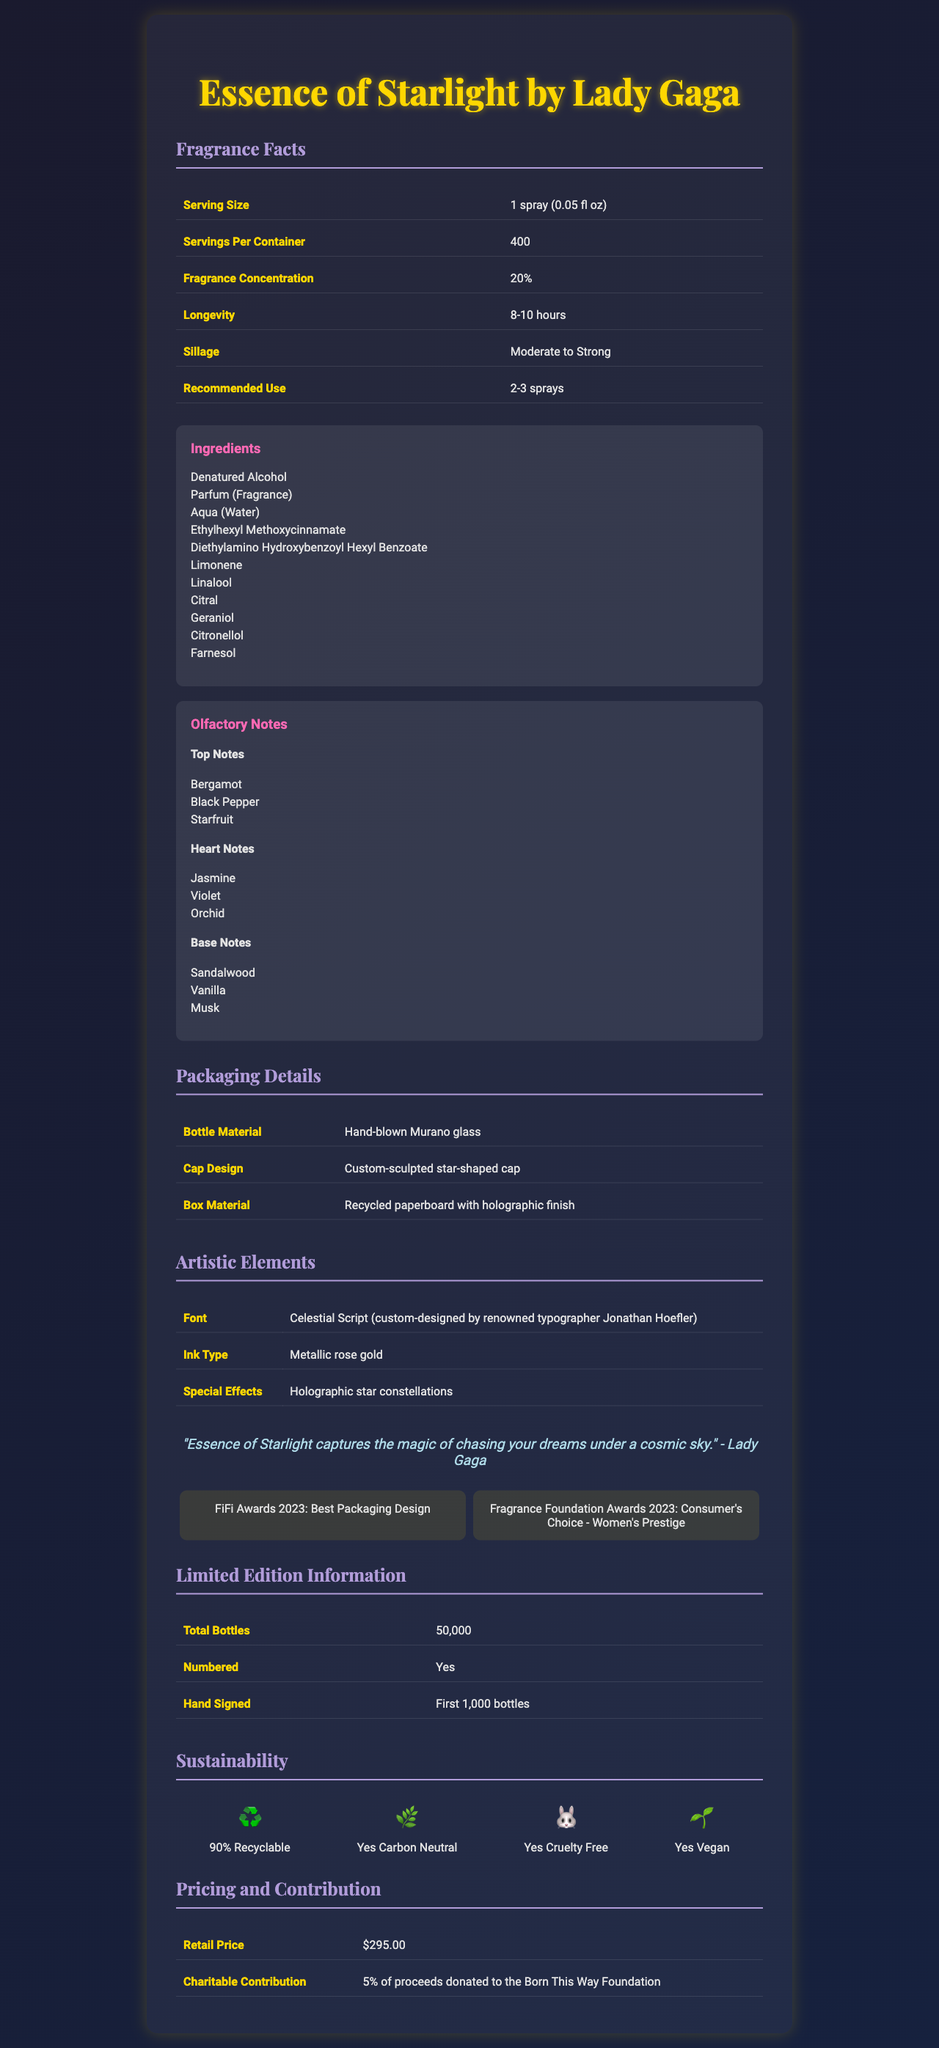what is the product name? The product name is listed at the top of the document and prominently titled "Essence of Starlight by Lady Gaga".
Answer: Essence of Starlight by Lady Gaga what is the fragrance concentration percentage? The fragrance concentration of the perfume is given in the Fragrance Facts table as 20%.
Answer: 20% what are the top notes of the perfume? The top notes are listed under the olfactory notes section of the document.
Answer: Bergamot, Black Pepper, Starfruit what material is the bottle made of? The bottle material is listed under the Packaging Details section.
Answer: Hand-blown Murano glass who custom-designed the font used in this document? The font, named Celestial Script, is custom-designed by renowned typographer Jonathan Hoefler and is detailed under Artistic Elements.
Answer: Jonathan Hoefler what is the retail price of the perfume? The retail price is mentioned in the Pricing and Contribution section as $295.00.
Answer: $295.00 how long does the fragrance last? (Longevity) The longevity of the fragrance is stated in the Fragrance Facts table as 8-10 hours.
Answer: 8-10 hours what special effects are incorporated in the packaging design? A. Metallic shimmer B. Sparkling crystals C. Holographic star constellations D. Embedded glitter The special effects are described as holographic star constellations under the Artistic Elements.
Answer: C. Holographic star constellations how many total bottles of this limited edition perfume were produced? A. 10,000 B. 25,000 C. 50,000 D. 100,000 The total number of bottles produced is stated in the Limited Edition Information section as 50,000.
Answer: C. 50,000 is the product cruelty-free? The document states that the product is cruelty-free in the Sustainability section.
Answer: Yes summarize the main features and design elements of this perfume label This summary encapsulates the main aspects of the perfume, including its fragrance notes, packaging materials, artistic design, sustainability features, retail price, and charitable contribution.
Answer: Essence of Starlight by Lady Gaga is a limited edition perfume that boasts a 20% fragrance concentration, lasting 8-10 hours with moderate to strong sillage. The top notes include Bergamot, Black Pepper, and Starfruit, while the base notes feature Sandalwood, Vanilla, and Musk. The bottle is made of hand-blown Murano glass and has a custom-sculpted star-shaped cap. The font, crafted by Jonathan Hoefler, is printed with metallic rose gold ink and features holographic star constellations. The product is carbon neutral, cruelty-free, vegan, and 90% recyclable, with a retail price of $295.00 and 5% of proceeds donated to the Born This Way Foundation. how many ingredients are listed in the ingredients section? The ingredients section lists a total of 10 ingredients.
Answer: 10 what percentage of the components are recyclable? The recyclability of the components is mentioned in the Sustainability section as 90%.
Answer: 90% has the product won any awards? The document lists two awards: FiFi Awards 2023 for Best Packaging Design and Fragrance Foundation Awards 2023 - Consumer's Choice for Women's Prestige.
Answer: Yes is this document sufficient for developing a new marketing strategy for the perfume? The document provides detailed features and design elements of the perfume but may lack other vital market analysis data, competitor insights, and customer demographics required for developing a new marketing strategy.
Answer: Not enough information 